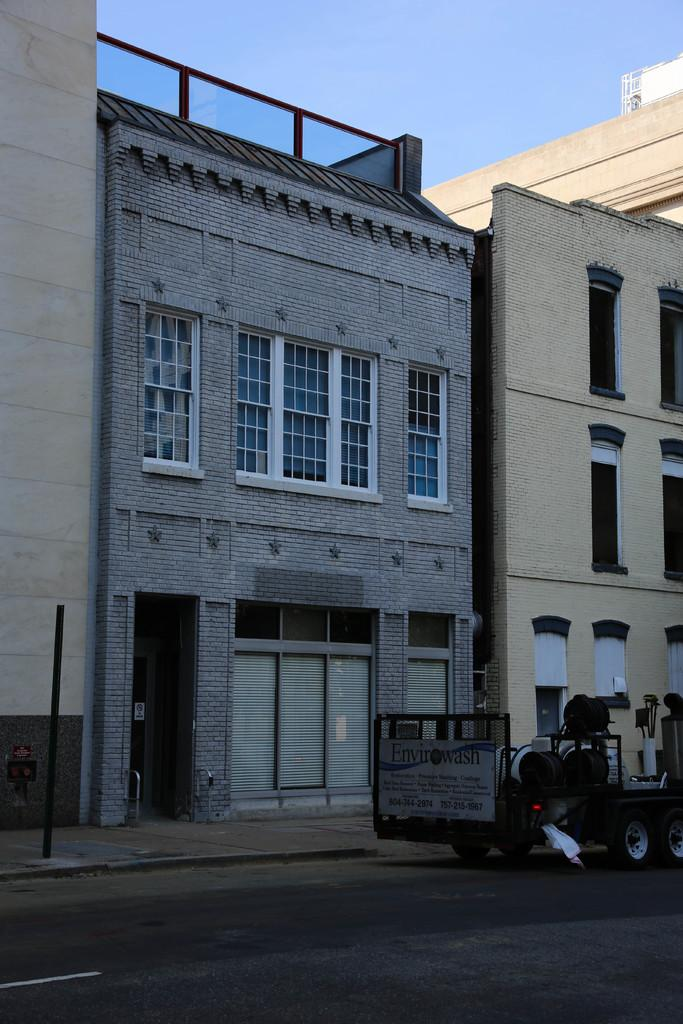What type of structures can be seen in the image? There are buildings in the image. What else can be seen on the ground in the image? There is a vehicle on the road in the image. How many arches can be seen on the vehicle in the image? There are no arches present on the vehicle in the image. What is the skill level of the driver of the vehicle in the image? The skill level of the driver cannot be determined from the image. 